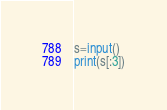<code> <loc_0><loc_0><loc_500><loc_500><_Python_>s=input()
print(s[:3])</code> 